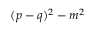Convert formula to latex. <formula><loc_0><loc_0><loc_500><loc_500>( p - q ) ^ { 2 } - m ^ { 2 }</formula> 